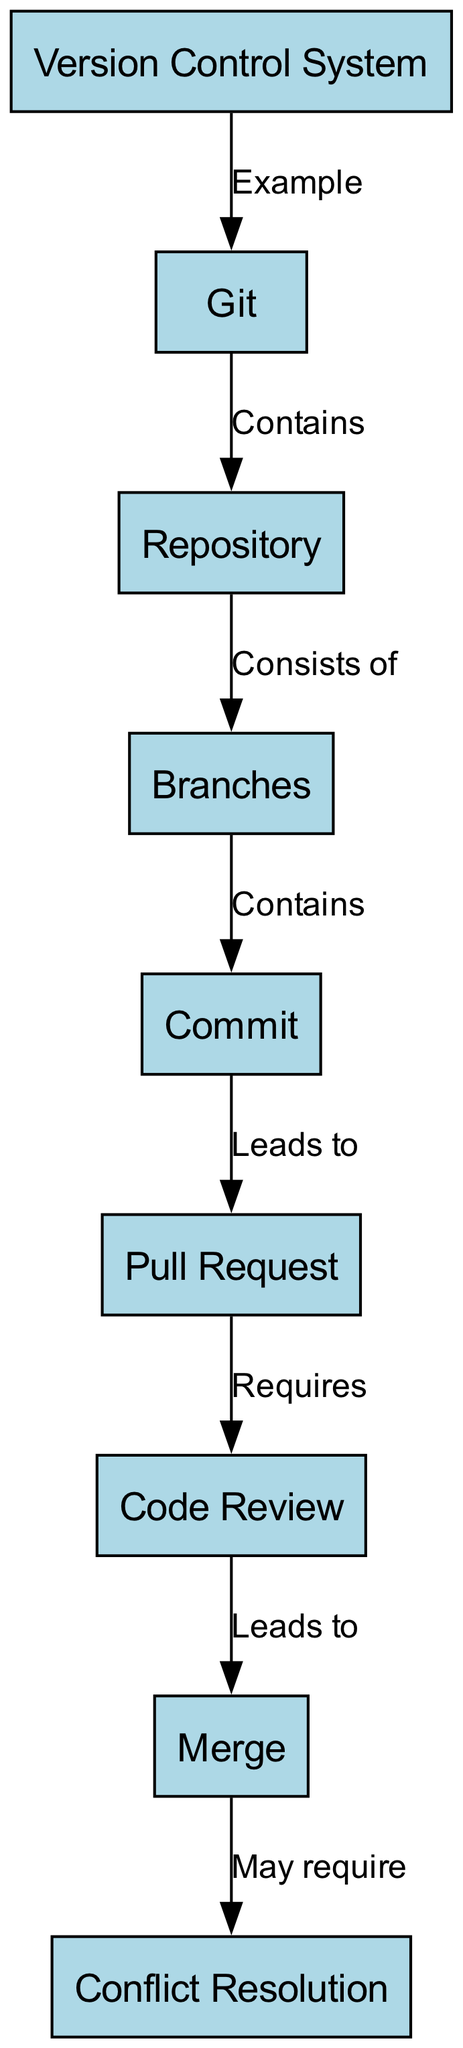What is an example of a Version Control System? "Git" is labeled as an example of a Version Control System in the diagram. The edge between node "1" (Version Control System) and node "2" (Git) confirms this.
Answer: Git What do repositories consist of? The diagram states that a Repository consists of Branches. This is shown as an edge labeled "Consists of" from node "3" (Repository) to node "4" (Branches).
Answer: Branches How many nodes are in the diagram? Counting each unique node in the diagram reveals there are a total of nine nodes. Each node is listed in the nodes section of the data.
Answer: Nine What follows a Commit in the workflow? According to the diagram, a Commit leads to a Pull Request. This relationship is indicated by the edge labeled "Leads to" from node "5" (Commit) to node "6" (Pull Request).
Answer: Pull Request What may require Conflict Resolution? The diagram indicates that the Merge may require Conflict Resolution. This is depicted by the edge labeled "May require" from node "8" (Merge) to node "9" (Conflict Resolution).
Answer: Conflict Resolution Which node is directly linked to Code Review? The Code Review node is directly linked to the Pull Request node. The edge labeled "Requires" connects node "6" (Pull Request) to node "7" (Code Review), showing that a Code Review is required by a Pull Request.
Answer: Pull Request How many edges are there in the diagram? The edges are the connections between the nodes. Counting all edges depicted shows there are a total of eight edges in the diagram.
Answer: Eight What is the flow from Branches to Conflict Resolution? The flow starts at Branches (node "4") which contains Commits (node "5"). This leads to Pull Requests (node "6"), followed by Code Review (node "7"), then to Merge (node "8"). Finally, it may require Conflict Resolution (node "9"). Therefore, the path is: Branches -> Commits -> Pull Request -> Code Review -> Merge -> Conflict Resolution.
Answer: Branches -> Commits -> Pull Request -> Code Review -> Merge -> Conflict Resolution 